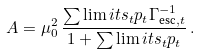Convert formula to latex. <formula><loc_0><loc_0><loc_500><loc_500>A = \mu _ { 0 } ^ { 2 } \, \frac { \sum \lim i t s _ { t } p _ { t } \Gamma _ { \text {esc} , t } ^ { - 1 } } { 1 + \sum \lim i t s _ { t } p _ { t } } \, .</formula> 